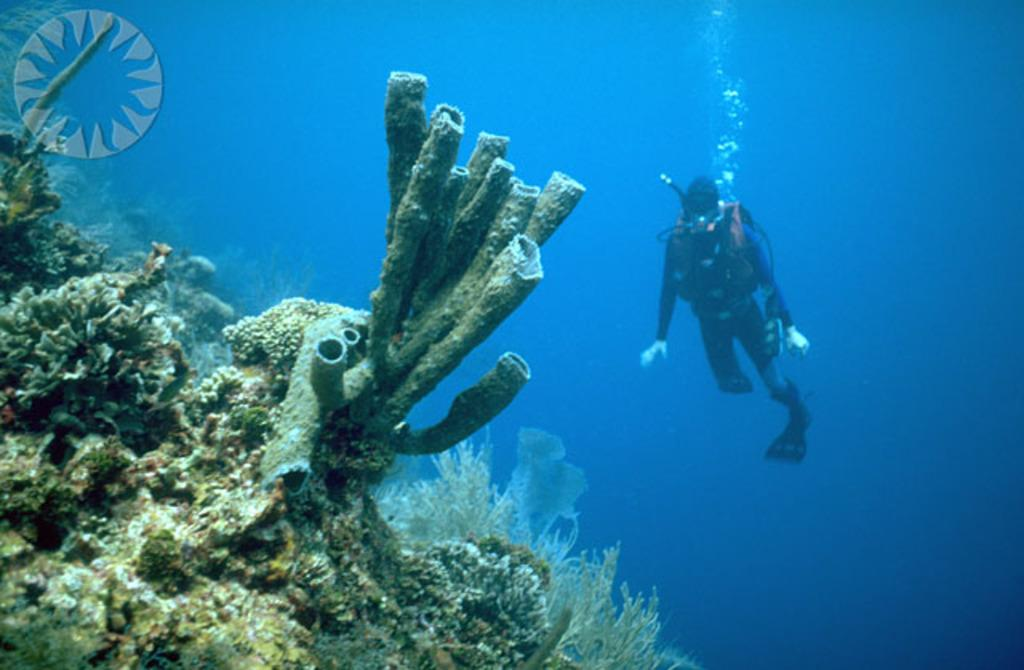What type of marine life can be seen in the image? There are corals and sea lettuce in the image. What is the color of the water in the background of the image? The background of the image is blue water. What activity is the person in the image engaged in? The person is diving in the water. Is there any text or symbol in the image? Yes, there is a logo in the top left corner of the image. What type of impulse does the person feel while diving in the image? There is no information about the person's feelings or impulses in the image. Can you see a rod being used by the person in the image? No, there is no rod visible in the image. 